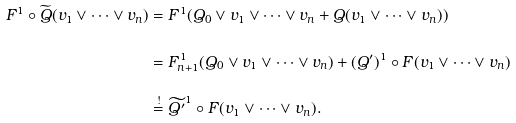Convert formula to latex. <formula><loc_0><loc_0><loc_500><loc_500>F ^ { 1 } \circ \widetilde { Q } ( v _ { 1 } \vee \cdots \vee v _ { n } ) & = F ^ { 1 } ( Q _ { 0 } \vee v _ { 1 } \vee \cdots \vee v _ { n } + Q ( v _ { 1 } \vee \cdots \vee v _ { n } ) ) \\ & = F _ { n + 1 } ^ { 1 } ( Q _ { 0 } \vee v _ { 1 } \vee \cdots \vee v _ { n } ) + ( Q ^ { \prime } ) ^ { 1 } \circ F ( v _ { 1 } \vee \cdots \vee v _ { n } ) \\ & \stackrel { ! } { = } \widetilde { Q ^ { \prime } } ^ { 1 } \circ F ( v _ { 1 } \vee \cdots \vee v _ { n } ) .</formula> 